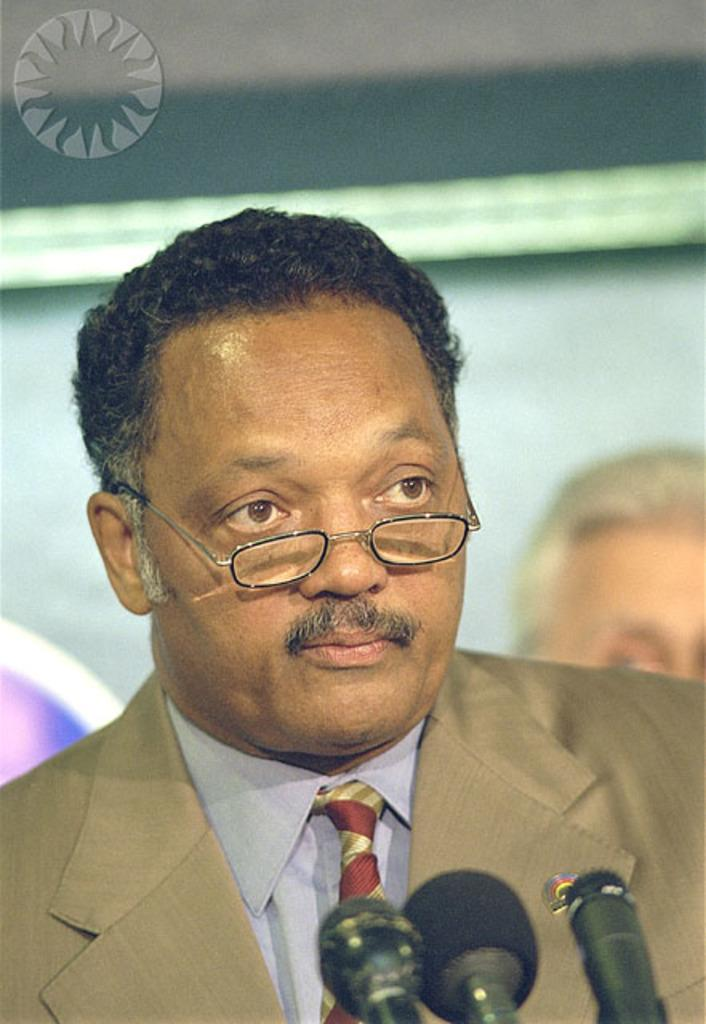Who is present in the image? There is a man in the image. What is the man wearing? The man is wearing spectacles. What objects can be seen at the bottom of the image? There are microphones at the bottom of the image. What can be seen in the image that represents a brand or organization? There is a logo in the image. Can you describe any other elements in the image? There are a few unspecified things in the image. Whose head is visible in the image? The head of a person is visible in the image. How many centimeters of force is the man applying to the microphone in the image? There is no information about the force applied to the microphone in the image, and the unit of measurement "centimeters" is not relevant to the context. 